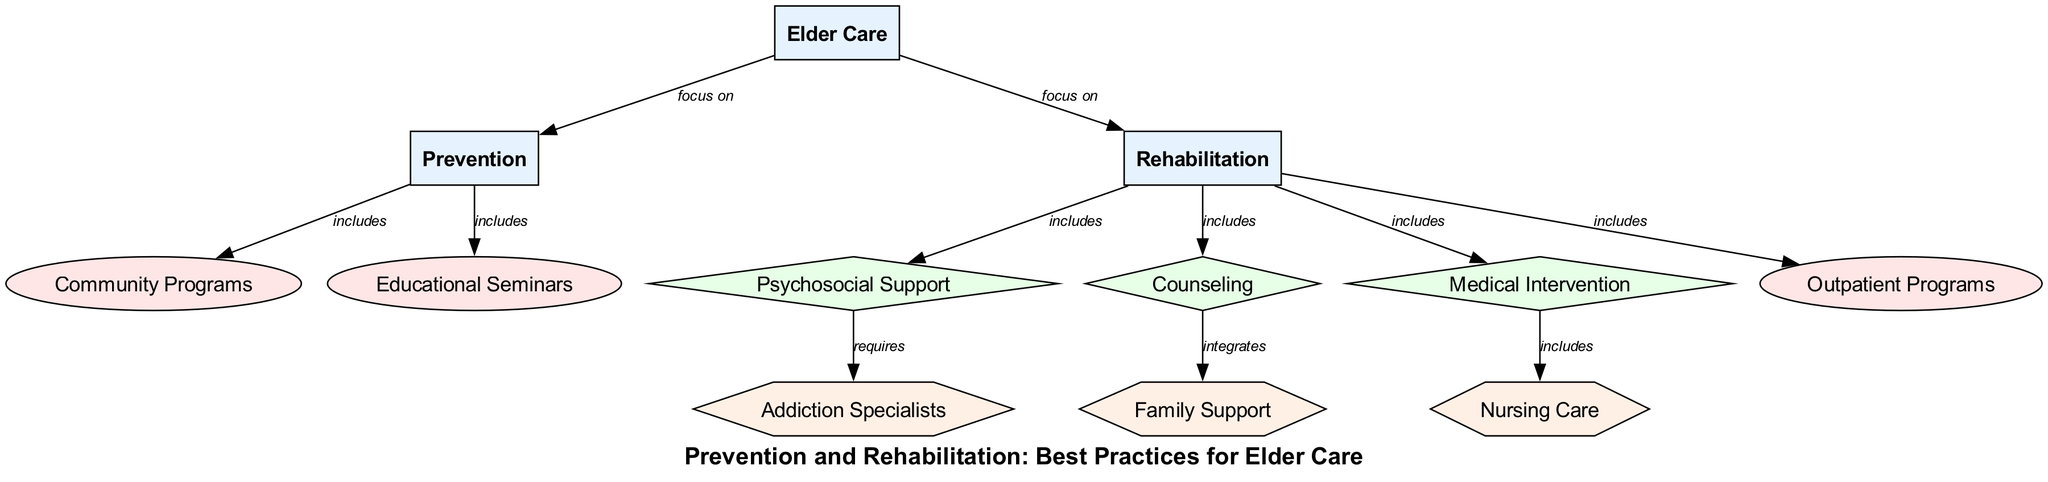What are the two main focuses of elder care in the diagram? The diagram shows two main focuses under the category "Elder Care": Prevention and Rehabilitation. This is directly observable as there are arrows originating from "Elder Care" pointing to both "Prevention" and "Rehabilitation."
Answer: Prevention and Rehabilitation How many methods are included under the prevention category? The prevention category includes two methods as illustrated by the arrows leading to "Community Programs" and "Educational Seminars." Counting these two edges gives the total.
Answer: 2 Which approach requires addiction specialists? Looking at the edges in the diagram, "Psychosocial Support" is the only approach that specifically requires "Addiction Specialists," as indicated by the arrow from "Psychosocial Support" to "Addiction Specialists."
Answer: Psychosocial Support What type of support integrates family support according to the diagram? The diagram indicates that "Counseling" integrates "Family Support," as shown by the edge that connects these two nodes. Therefore, counseling is the answer.
Answer: Counseling How many nodes are categorized as resources in this diagram? Analyzing the diagram, there are three nodes categorized as resources: "Addiction Specialists," "Family Support," and "Nursing Care." The count of these resource nodes is three.
Answer: 3 What is included under the rehabilitation category? The rehabilitation category includes four elements: "Psychosocial Support," "Counseling," "Medical Intervention," and "Outpatient Programs." The edges originating from "Rehabilitation" point to these four methods, reflecting their inclusion.
Answer: Psychosocial Support, Counseling, Medical Intervention, Outpatient Programs Which resource is included in medical intervention? According to the diagram, "Nursing Care" is specifically included within the "Medical Intervention" category, as seen in the edge directed from "Medical Intervention" to "Nursing Care."
Answer: Nursing Care What is the relationship between counseling and family support? The diagram shows a direct relationship where "Counseling" integrates "Family Support," indicated by the arrow pointing from "Counseling" to "Family Support." Thus, the relationship is integration.
Answer: Integrates 